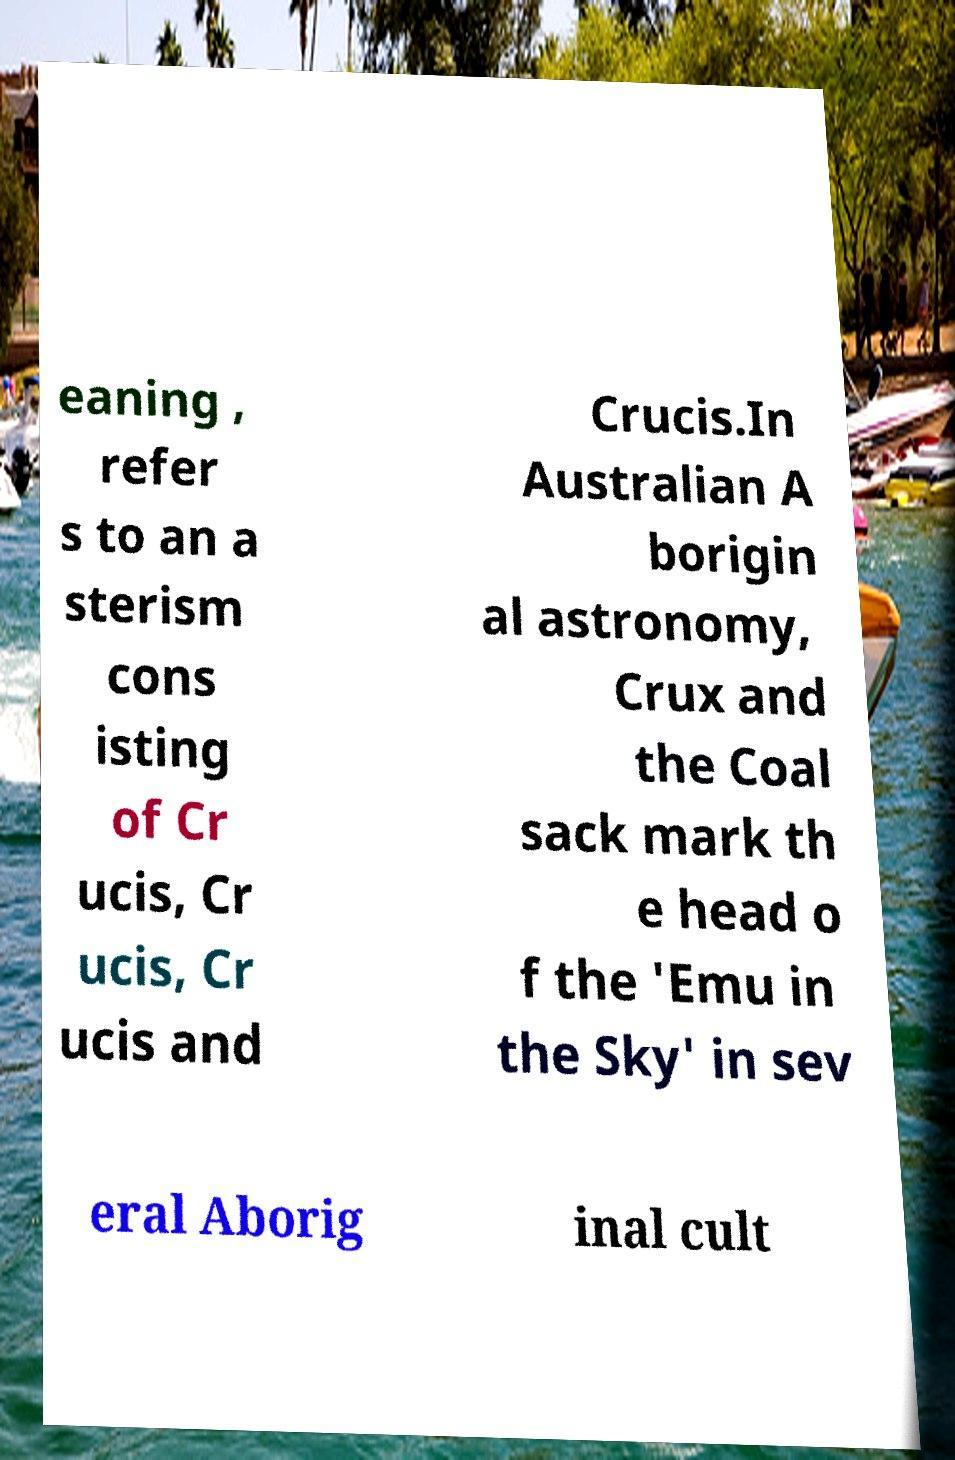What messages or text are displayed in this image? I need them in a readable, typed format. eaning , refer s to an a sterism cons isting of Cr ucis, Cr ucis, Cr ucis and Crucis.In Australian A borigin al astronomy, Crux and the Coal sack mark th e head o f the 'Emu in the Sky' in sev eral Aborig inal cult 